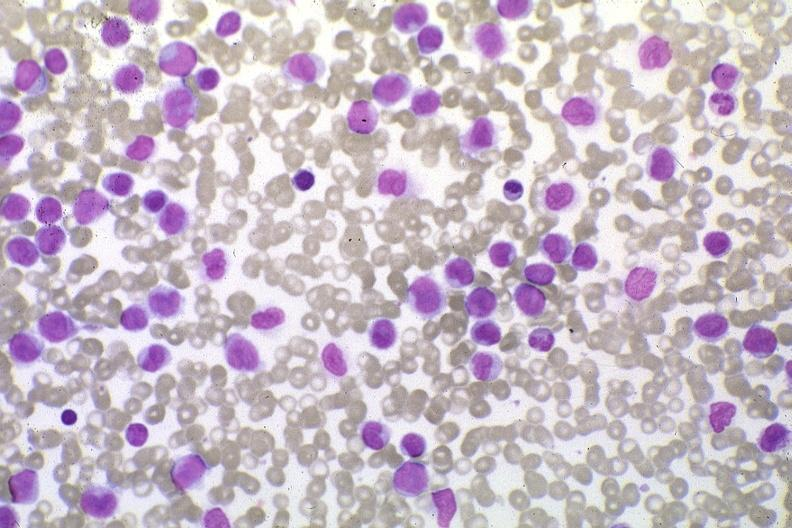s acute monocytic leukemia present?
Answer the question using a single word or phrase. Yes 